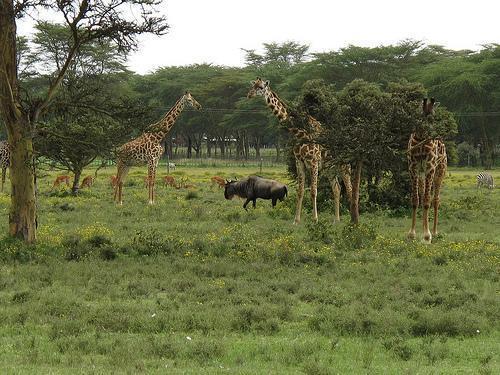How many giraffes are there?
Give a very brief answer. 3. How many different types of animals are pictured here?
Give a very brief answer. 3. How many giraffes are pictured?
Give a very brief answer. 3. How many zebra are shown?
Give a very brief answer. 1. 